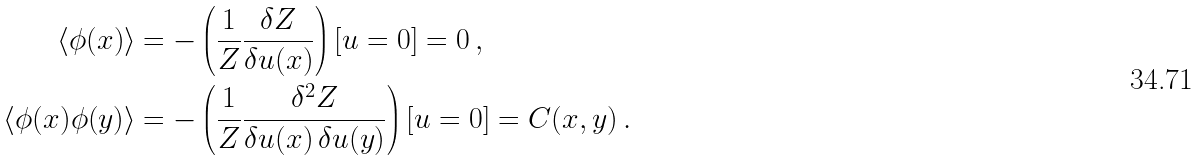Convert formula to latex. <formula><loc_0><loc_0><loc_500><loc_500>\langle \phi ( x ) \rangle & = - \left ( \frac { 1 } { Z } \frac { \delta Z } { \delta u ( x ) } \right ) [ u = 0 ] = 0 \, , \\ \langle \phi ( x ) \phi ( y ) \rangle & = - \left ( \frac { 1 } { Z } \frac { \delta ^ { 2 } Z } { \delta u ( x ) \, \delta u ( y ) } \right ) [ u = 0 ] = C ( x , y ) \, .</formula> 